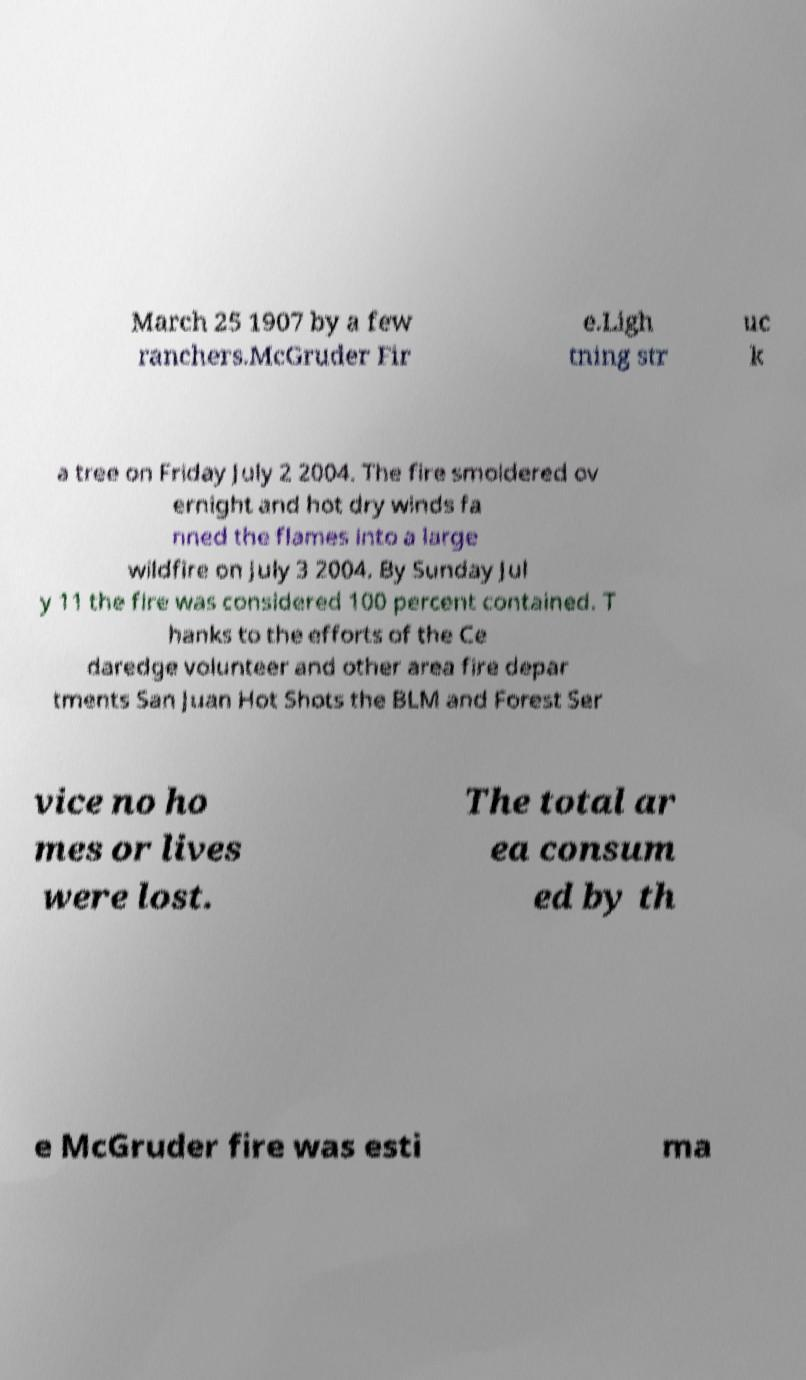Could you extract and type out the text from this image? March 25 1907 by a few ranchers.McGruder Fir e.Ligh tning str uc k a tree on Friday July 2 2004. The fire smoldered ov ernight and hot dry winds fa nned the flames into a large wildfire on July 3 2004. By Sunday Jul y 11 the fire was considered 100 percent contained. T hanks to the efforts of the Ce daredge volunteer and other area fire depar tments San Juan Hot Shots the BLM and Forest Ser vice no ho mes or lives were lost. The total ar ea consum ed by th e McGruder fire was esti ma 